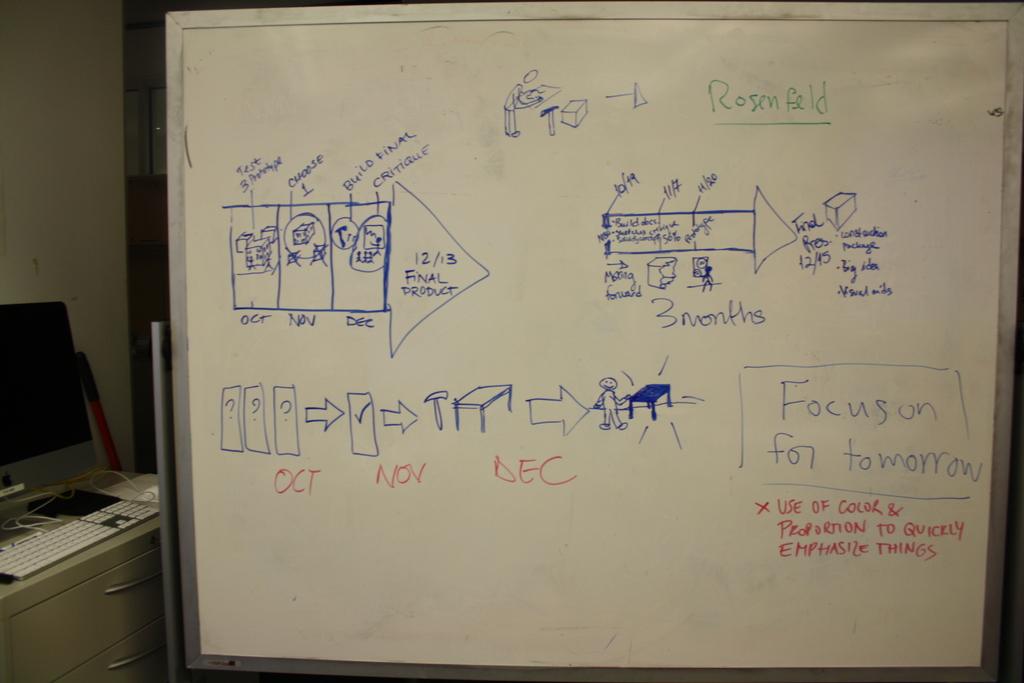The board says to focus on for when?
Your answer should be compact. Tomorrow. How many colors are on the board?
Provide a succinct answer. Answering does not require reading text in the image. 